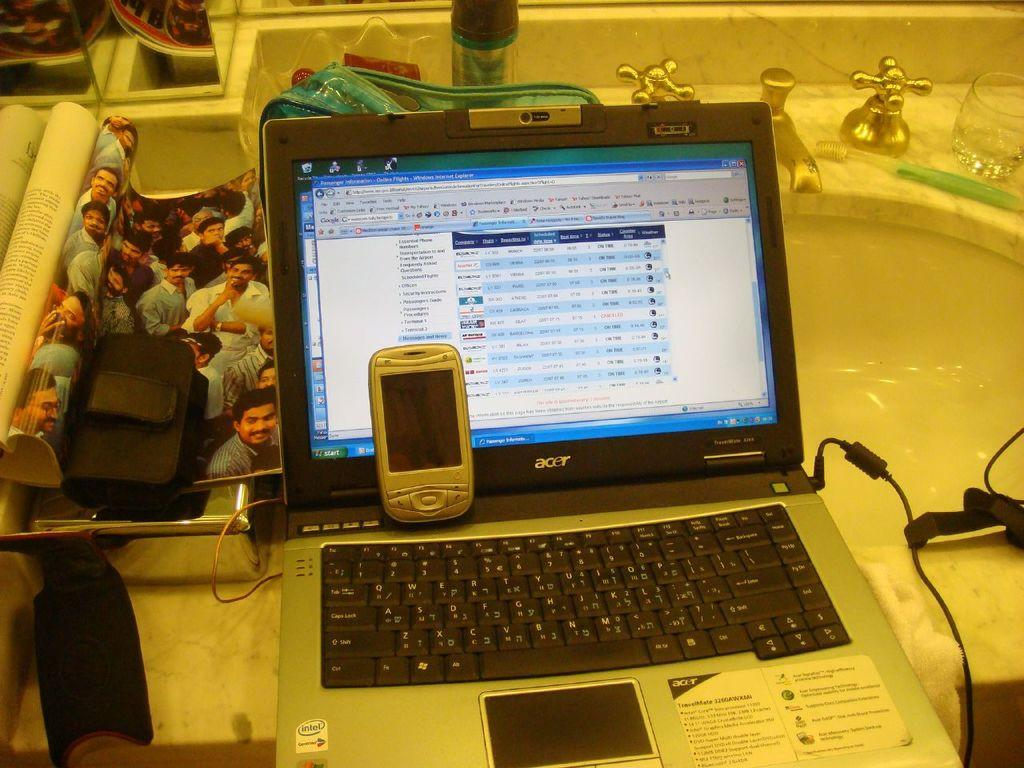<image>
Share a concise interpretation of the image provided. an Acer lap top computer has an old silver cell phone on it 